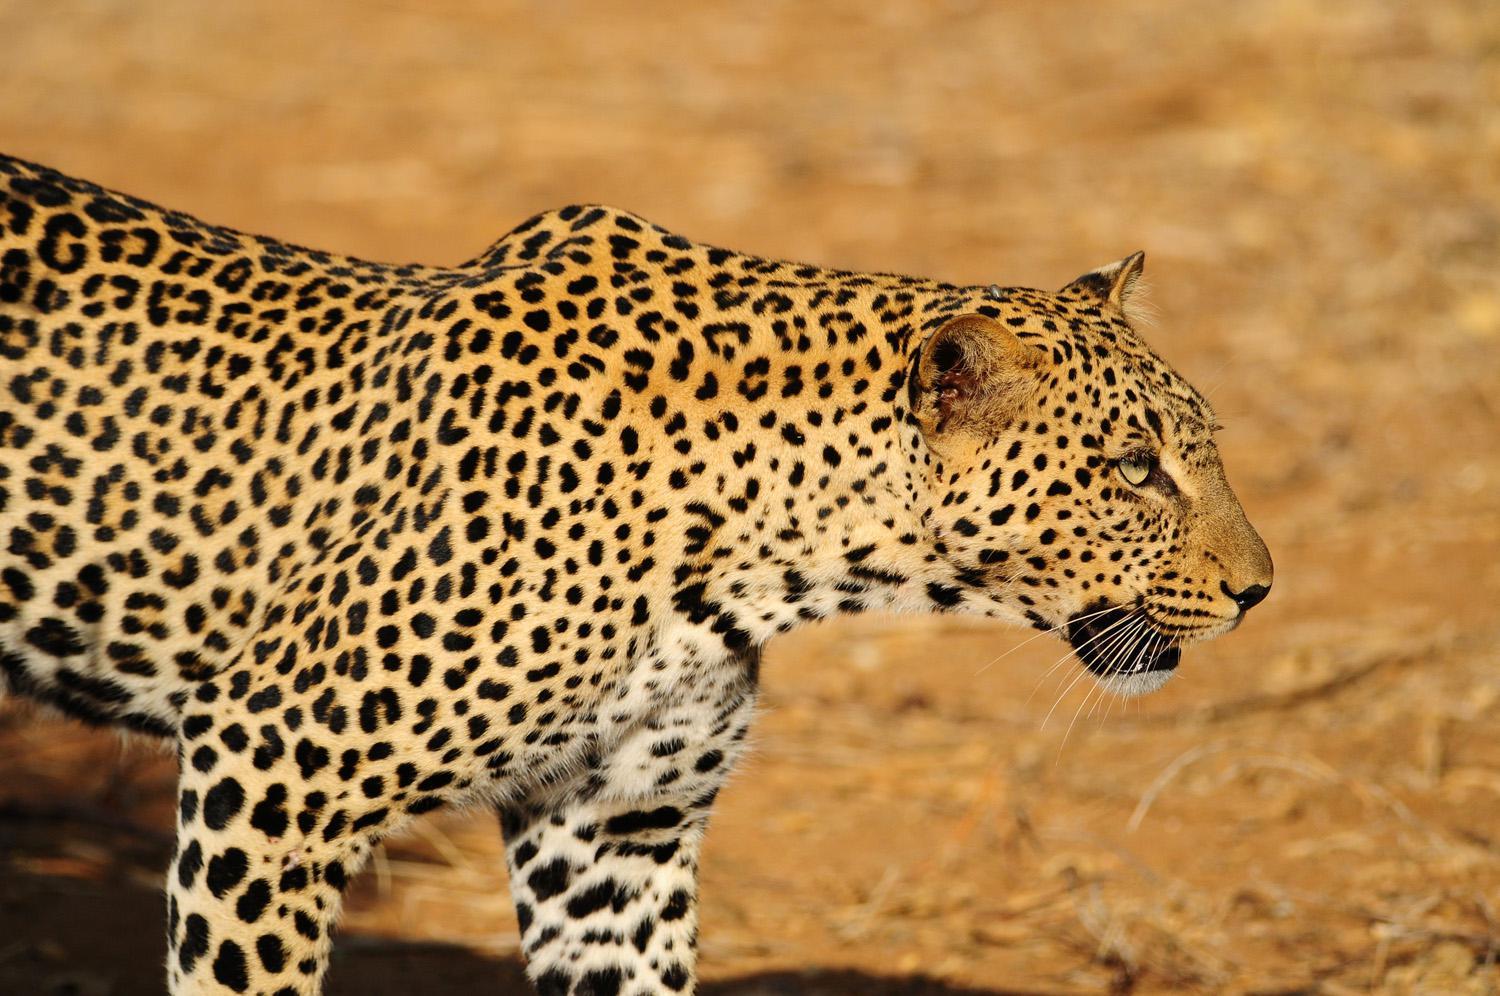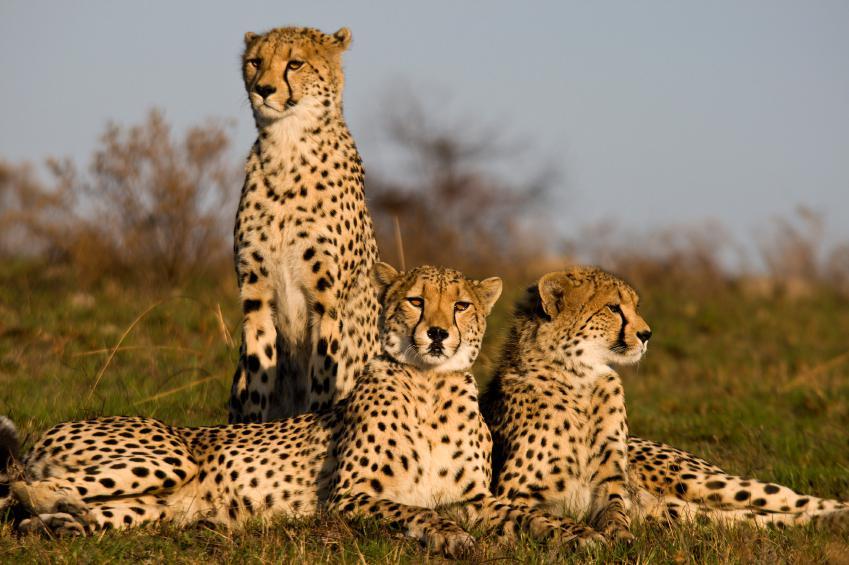The first image is the image on the left, the second image is the image on the right. Analyze the images presented: Is the assertion "Two of the cats in the image on the right are lying on the ground." valid? Answer yes or no. Yes. The first image is the image on the left, the second image is the image on the right. Examine the images to the left and right. Is the description "The right image contains no more than two cheetahs." accurate? Answer yes or no. No. 